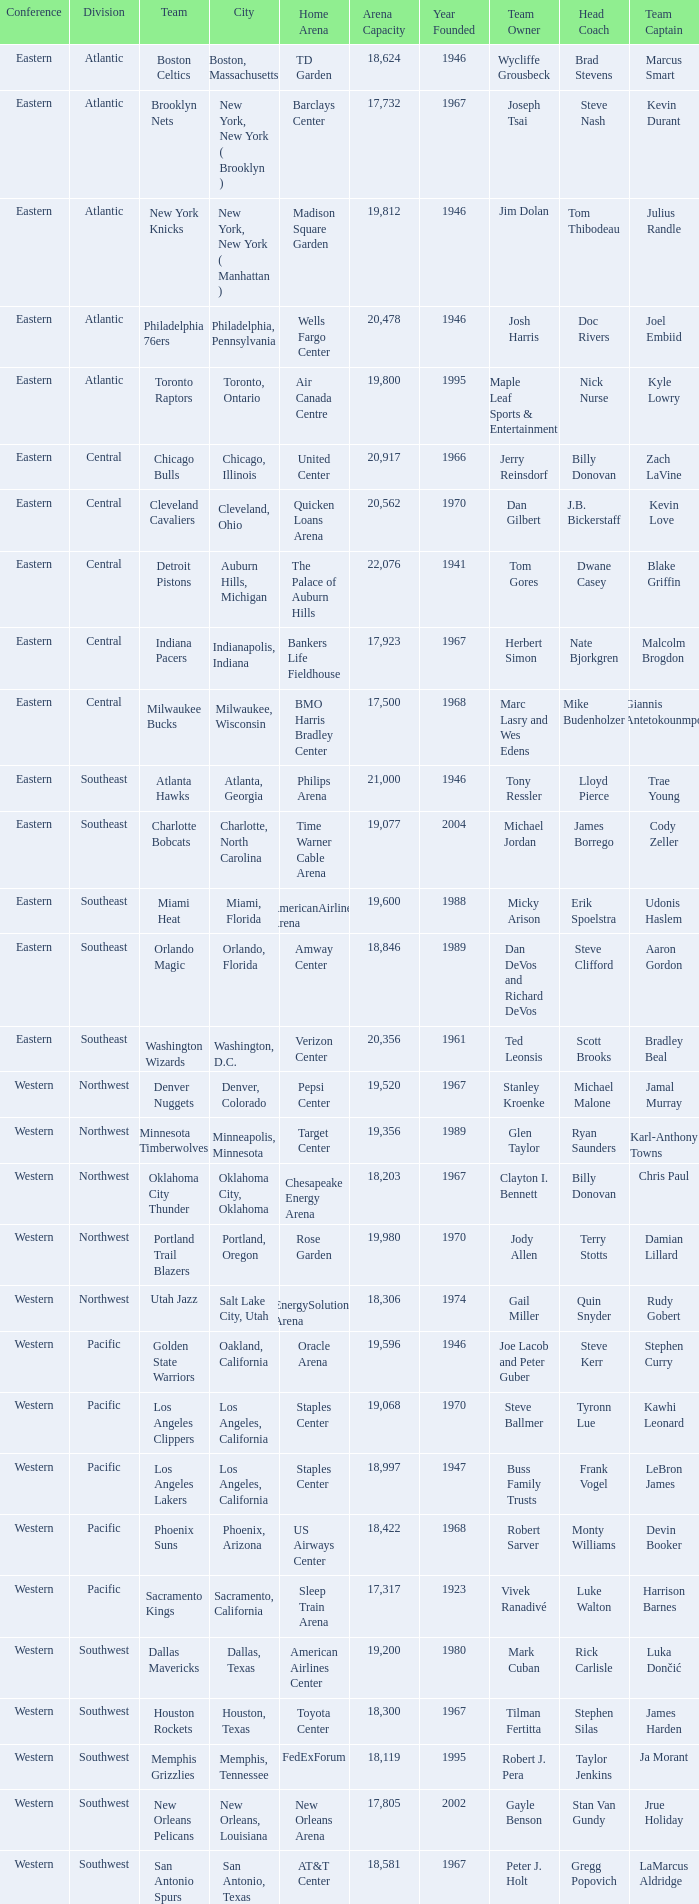Which conference is in Portland, Oregon? Western. 